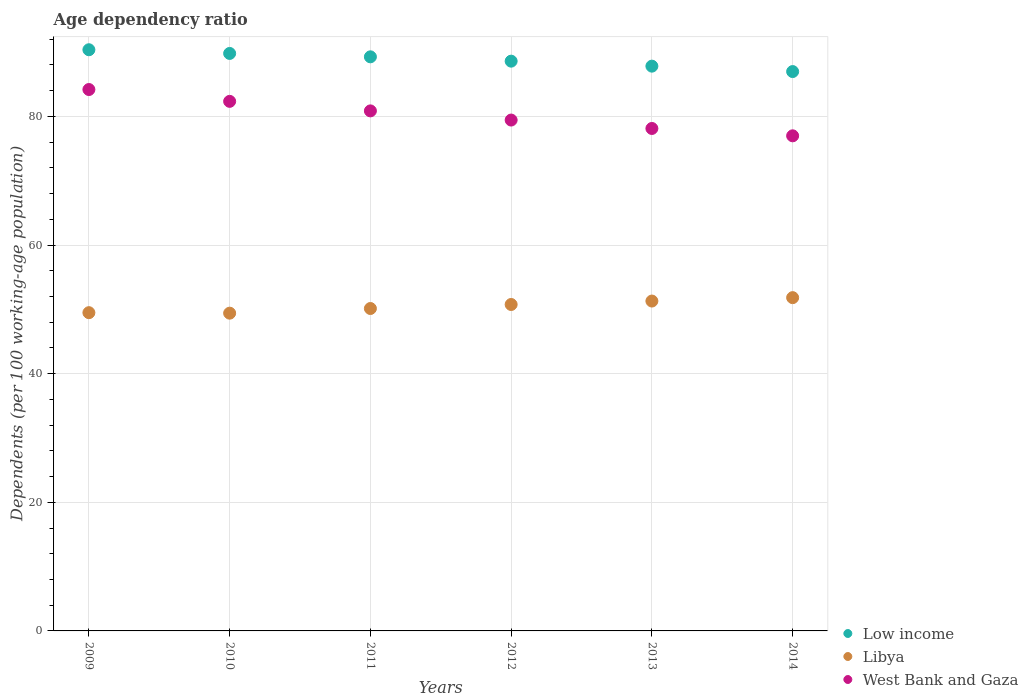Is the number of dotlines equal to the number of legend labels?
Offer a terse response. Yes. What is the age dependency ratio in in Low income in 2013?
Give a very brief answer. 87.81. Across all years, what is the maximum age dependency ratio in in Libya?
Offer a terse response. 51.82. Across all years, what is the minimum age dependency ratio in in West Bank and Gaza?
Keep it short and to the point. 76.98. In which year was the age dependency ratio in in Libya maximum?
Your answer should be compact. 2014. What is the total age dependency ratio in in Low income in the graph?
Offer a very short reply. 532.76. What is the difference between the age dependency ratio in in West Bank and Gaza in 2010 and that in 2012?
Your answer should be very brief. 2.91. What is the difference between the age dependency ratio in in Low income in 2011 and the age dependency ratio in in West Bank and Gaza in 2012?
Your answer should be compact. 9.83. What is the average age dependency ratio in in Low income per year?
Provide a succinct answer. 88.79. In the year 2012, what is the difference between the age dependency ratio in in Libya and age dependency ratio in in West Bank and Gaza?
Your answer should be compact. -28.68. What is the ratio of the age dependency ratio in in Libya in 2009 to that in 2010?
Make the answer very short. 1. Is the age dependency ratio in in Low income in 2009 less than that in 2011?
Your answer should be very brief. No. Is the difference between the age dependency ratio in in Libya in 2011 and 2013 greater than the difference between the age dependency ratio in in West Bank and Gaza in 2011 and 2013?
Provide a succinct answer. No. What is the difference between the highest and the second highest age dependency ratio in in Libya?
Your answer should be compact. 0.53. What is the difference between the highest and the lowest age dependency ratio in in Libya?
Make the answer very short. 2.41. Is it the case that in every year, the sum of the age dependency ratio in in West Bank and Gaza and age dependency ratio in in Libya  is greater than the age dependency ratio in in Low income?
Provide a succinct answer. Yes. Does the age dependency ratio in in West Bank and Gaza monotonically increase over the years?
Ensure brevity in your answer.  No. How many years are there in the graph?
Give a very brief answer. 6. What is the difference between two consecutive major ticks on the Y-axis?
Your answer should be very brief. 20. Are the values on the major ticks of Y-axis written in scientific E-notation?
Provide a short and direct response. No. Does the graph contain any zero values?
Give a very brief answer. No. Does the graph contain grids?
Ensure brevity in your answer.  Yes. What is the title of the graph?
Your answer should be very brief. Age dependency ratio. What is the label or title of the Y-axis?
Offer a very short reply. Dependents (per 100 working-age population). What is the Dependents (per 100 working-age population) in Low income in 2009?
Give a very brief answer. 90.36. What is the Dependents (per 100 working-age population) in Libya in 2009?
Ensure brevity in your answer.  49.48. What is the Dependents (per 100 working-age population) of West Bank and Gaza in 2009?
Ensure brevity in your answer.  84.17. What is the Dependents (per 100 working-age population) in Low income in 2010?
Offer a very short reply. 89.78. What is the Dependents (per 100 working-age population) in Libya in 2010?
Your answer should be compact. 49.4. What is the Dependents (per 100 working-age population) of West Bank and Gaza in 2010?
Your answer should be very brief. 82.33. What is the Dependents (per 100 working-age population) in Low income in 2011?
Your response must be concise. 89.26. What is the Dependents (per 100 working-age population) in Libya in 2011?
Your answer should be compact. 50.13. What is the Dependents (per 100 working-age population) of West Bank and Gaza in 2011?
Provide a short and direct response. 80.85. What is the Dependents (per 100 working-age population) in Low income in 2012?
Your answer should be compact. 88.58. What is the Dependents (per 100 working-age population) of Libya in 2012?
Give a very brief answer. 50.75. What is the Dependents (per 100 working-age population) of West Bank and Gaza in 2012?
Your response must be concise. 79.43. What is the Dependents (per 100 working-age population) of Low income in 2013?
Offer a very short reply. 87.81. What is the Dependents (per 100 working-age population) in Libya in 2013?
Your response must be concise. 51.29. What is the Dependents (per 100 working-age population) in West Bank and Gaza in 2013?
Offer a terse response. 78.12. What is the Dependents (per 100 working-age population) in Low income in 2014?
Ensure brevity in your answer.  86.97. What is the Dependents (per 100 working-age population) of Libya in 2014?
Your response must be concise. 51.82. What is the Dependents (per 100 working-age population) in West Bank and Gaza in 2014?
Provide a short and direct response. 76.98. Across all years, what is the maximum Dependents (per 100 working-age population) of Low income?
Your answer should be compact. 90.36. Across all years, what is the maximum Dependents (per 100 working-age population) in Libya?
Your answer should be very brief. 51.82. Across all years, what is the maximum Dependents (per 100 working-age population) of West Bank and Gaza?
Make the answer very short. 84.17. Across all years, what is the minimum Dependents (per 100 working-age population) in Low income?
Your answer should be very brief. 86.97. Across all years, what is the minimum Dependents (per 100 working-age population) in Libya?
Your answer should be very brief. 49.4. Across all years, what is the minimum Dependents (per 100 working-age population) in West Bank and Gaza?
Give a very brief answer. 76.98. What is the total Dependents (per 100 working-age population) of Low income in the graph?
Make the answer very short. 532.76. What is the total Dependents (per 100 working-age population) of Libya in the graph?
Provide a succinct answer. 302.86. What is the total Dependents (per 100 working-age population) in West Bank and Gaza in the graph?
Your answer should be compact. 481.88. What is the difference between the Dependents (per 100 working-age population) in Low income in 2009 and that in 2010?
Offer a terse response. 0.57. What is the difference between the Dependents (per 100 working-age population) in Libya in 2009 and that in 2010?
Give a very brief answer. 0.08. What is the difference between the Dependents (per 100 working-age population) in West Bank and Gaza in 2009 and that in 2010?
Give a very brief answer. 1.84. What is the difference between the Dependents (per 100 working-age population) in Low income in 2009 and that in 2011?
Provide a short and direct response. 1.1. What is the difference between the Dependents (per 100 working-age population) of Libya in 2009 and that in 2011?
Ensure brevity in your answer.  -0.65. What is the difference between the Dependents (per 100 working-age population) in West Bank and Gaza in 2009 and that in 2011?
Provide a short and direct response. 3.32. What is the difference between the Dependents (per 100 working-age population) in Low income in 2009 and that in 2012?
Your response must be concise. 1.77. What is the difference between the Dependents (per 100 working-age population) in Libya in 2009 and that in 2012?
Offer a terse response. -1.27. What is the difference between the Dependents (per 100 working-age population) in West Bank and Gaza in 2009 and that in 2012?
Your response must be concise. 4.75. What is the difference between the Dependents (per 100 working-age population) in Low income in 2009 and that in 2013?
Make the answer very short. 2.55. What is the difference between the Dependents (per 100 working-age population) in Libya in 2009 and that in 2013?
Make the answer very short. -1.81. What is the difference between the Dependents (per 100 working-age population) in West Bank and Gaza in 2009 and that in 2013?
Keep it short and to the point. 6.06. What is the difference between the Dependents (per 100 working-age population) of Low income in 2009 and that in 2014?
Offer a terse response. 3.39. What is the difference between the Dependents (per 100 working-age population) in Libya in 2009 and that in 2014?
Keep it short and to the point. -2.34. What is the difference between the Dependents (per 100 working-age population) in West Bank and Gaza in 2009 and that in 2014?
Make the answer very short. 7.2. What is the difference between the Dependents (per 100 working-age population) in Low income in 2010 and that in 2011?
Your answer should be compact. 0.53. What is the difference between the Dependents (per 100 working-age population) of Libya in 2010 and that in 2011?
Your answer should be very brief. -0.72. What is the difference between the Dependents (per 100 working-age population) in West Bank and Gaza in 2010 and that in 2011?
Offer a terse response. 1.48. What is the difference between the Dependents (per 100 working-age population) in Low income in 2010 and that in 2012?
Give a very brief answer. 1.2. What is the difference between the Dependents (per 100 working-age population) of Libya in 2010 and that in 2012?
Keep it short and to the point. -1.35. What is the difference between the Dependents (per 100 working-age population) in West Bank and Gaza in 2010 and that in 2012?
Offer a very short reply. 2.91. What is the difference between the Dependents (per 100 working-age population) of Low income in 2010 and that in 2013?
Your response must be concise. 1.98. What is the difference between the Dependents (per 100 working-age population) in Libya in 2010 and that in 2013?
Keep it short and to the point. -1.89. What is the difference between the Dependents (per 100 working-age population) of West Bank and Gaza in 2010 and that in 2013?
Make the answer very short. 4.22. What is the difference between the Dependents (per 100 working-age population) of Low income in 2010 and that in 2014?
Offer a very short reply. 2.82. What is the difference between the Dependents (per 100 working-age population) of Libya in 2010 and that in 2014?
Make the answer very short. -2.41. What is the difference between the Dependents (per 100 working-age population) in West Bank and Gaza in 2010 and that in 2014?
Your answer should be very brief. 5.36. What is the difference between the Dependents (per 100 working-age population) of Low income in 2011 and that in 2012?
Offer a very short reply. 0.67. What is the difference between the Dependents (per 100 working-age population) in Libya in 2011 and that in 2012?
Your response must be concise. -0.62. What is the difference between the Dependents (per 100 working-age population) of West Bank and Gaza in 2011 and that in 2012?
Your answer should be very brief. 1.43. What is the difference between the Dependents (per 100 working-age population) in Low income in 2011 and that in 2013?
Keep it short and to the point. 1.45. What is the difference between the Dependents (per 100 working-age population) in Libya in 2011 and that in 2013?
Provide a succinct answer. -1.16. What is the difference between the Dependents (per 100 working-age population) in West Bank and Gaza in 2011 and that in 2013?
Give a very brief answer. 2.73. What is the difference between the Dependents (per 100 working-age population) in Low income in 2011 and that in 2014?
Your answer should be very brief. 2.29. What is the difference between the Dependents (per 100 working-age population) in Libya in 2011 and that in 2014?
Your answer should be compact. -1.69. What is the difference between the Dependents (per 100 working-age population) in West Bank and Gaza in 2011 and that in 2014?
Provide a short and direct response. 3.88. What is the difference between the Dependents (per 100 working-age population) in Low income in 2012 and that in 2013?
Your response must be concise. 0.78. What is the difference between the Dependents (per 100 working-age population) in Libya in 2012 and that in 2013?
Offer a terse response. -0.54. What is the difference between the Dependents (per 100 working-age population) in West Bank and Gaza in 2012 and that in 2013?
Provide a short and direct response. 1.31. What is the difference between the Dependents (per 100 working-age population) of Low income in 2012 and that in 2014?
Provide a succinct answer. 1.62. What is the difference between the Dependents (per 100 working-age population) in Libya in 2012 and that in 2014?
Offer a very short reply. -1.06. What is the difference between the Dependents (per 100 working-age population) in West Bank and Gaza in 2012 and that in 2014?
Offer a very short reply. 2.45. What is the difference between the Dependents (per 100 working-age population) in Low income in 2013 and that in 2014?
Your answer should be compact. 0.84. What is the difference between the Dependents (per 100 working-age population) of Libya in 2013 and that in 2014?
Give a very brief answer. -0.53. What is the difference between the Dependents (per 100 working-age population) of West Bank and Gaza in 2013 and that in 2014?
Your response must be concise. 1.14. What is the difference between the Dependents (per 100 working-age population) of Low income in 2009 and the Dependents (per 100 working-age population) of Libya in 2010?
Ensure brevity in your answer.  40.96. What is the difference between the Dependents (per 100 working-age population) of Low income in 2009 and the Dependents (per 100 working-age population) of West Bank and Gaza in 2010?
Keep it short and to the point. 8.02. What is the difference between the Dependents (per 100 working-age population) of Libya in 2009 and the Dependents (per 100 working-age population) of West Bank and Gaza in 2010?
Offer a very short reply. -32.85. What is the difference between the Dependents (per 100 working-age population) of Low income in 2009 and the Dependents (per 100 working-age population) of Libya in 2011?
Give a very brief answer. 40.23. What is the difference between the Dependents (per 100 working-age population) of Low income in 2009 and the Dependents (per 100 working-age population) of West Bank and Gaza in 2011?
Provide a short and direct response. 9.51. What is the difference between the Dependents (per 100 working-age population) of Libya in 2009 and the Dependents (per 100 working-age population) of West Bank and Gaza in 2011?
Ensure brevity in your answer.  -31.37. What is the difference between the Dependents (per 100 working-age population) of Low income in 2009 and the Dependents (per 100 working-age population) of Libya in 2012?
Your response must be concise. 39.61. What is the difference between the Dependents (per 100 working-age population) in Low income in 2009 and the Dependents (per 100 working-age population) in West Bank and Gaza in 2012?
Offer a very short reply. 10.93. What is the difference between the Dependents (per 100 working-age population) of Libya in 2009 and the Dependents (per 100 working-age population) of West Bank and Gaza in 2012?
Your answer should be compact. -29.95. What is the difference between the Dependents (per 100 working-age population) in Low income in 2009 and the Dependents (per 100 working-age population) in Libya in 2013?
Give a very brief answer. 39.07. What is the difference between the Dependents (per 100 working-age population) in Low income in 2009 and the Dependents (per 100 working-age population) in West Bank and Gaza in 2013?
Make the answer very short. 12.24. What is the difference between the Dependents (per 100 working-age population) of Libya in 2009 and the Dependents (per 100 working-age population) of West Bank and Gaza in 2013?
Your answer should be compact. -28.64. What is the difference between the Dependents (per 100 working-age population) in Low income in 2009 and the Dependents (per 100 working-age population) in Libya in 2014?
Make the answer very short. 38.54. What is the difference between the Dependents (per 100 working-age population) of Low income in 2009 and the Dependents (per 100 working-age population) of West Bank and Gaza in 2014?
Make the answer very short. 13.38. What is the difference between the Dependents (per 100 working-age population) in Libya in 2009 and the Dependents (per 100 working-age population) in West Bank and Gaza in 2014?
Keep it short and to the point. -27.5. What is the difference between the Dependents (per 100 working-age population) in Low income in 2010 and the Dependents (per 100 working-age population) in Libya in 2011?
Keep it short and to the point. 39.66. What is the difference between the Dependents (per 100 working-age population) of Low income in 2010 and the Dependents (per 100 working-age population) of West Bank and Gaza in 2011?
Ensure brevity in your answer.  8.93. What is the difference between the Dependents (per 100 working-age population) in Libya in 2010 and the Dependents (per 100 working-age population) in West Bank and Gaza in 2011?
Give a very brief answer. -31.45. What is the difference between the Dependents (per 100 working-age population) of Low income in 2010 and the Dependents (per 100 working-age population) of Libya in 2012?
Provide a succinct answer. 39.03. What is the difference between the Dependents (per 100 working-age population) in Low income in 2010 and the Dependents (per 100 working-age population) in West Bank and Gaza in 2012?
Make the answer very short. 10.36. What is the difference between the Dependents (per 100 working-age population) in Libya in 2010 and the Dependents (per 100 working-age population) in West Bank and Gaza in 2012?
Make the answer very short. -30.02. What is the difference between the Dependents (per 100 working-age population) of Low income in 2010 and the Dependents (per 100 working-age population) of Libya in 2013?
Your response must be concise. 38.5. What is the difference between the Dependents (per 100 working-age population) in Low income in 2010 and the Dependents (per 100 working-age population) in West Bank and Gaza in 2013?
Your response must be concise. 11.67. What is the difference between the Dependents (per 100 working-age population) in Libya in 2010 and the Dependents (per 100 working-age population) in West Bank and Gaza in 2013?
Offer a very short reply. -28.72. What is the difference between the Dependents (per 100 working-age population) in Low income in 2010 and the Dependents (per 100 working-age population) in Libya in 2014?
Give a very brief answer. 37.97. What is the difference between the Dependents (per 100 working-age population) of Low income in 2010 and the Dependents (per 100 working-age population) of West Bank and Gaza in 2014?
Ensure brevity in your answer.  12.81. What is the difference between the Dependents (per 100 working-age population) in Libya in 2010 and the Dependents (per 100 working-age population) in West Bank and Gaza in 2014?
Provide a succinct answer. -27.57. What is the difference between the Dependents (per 100 working-age population) of Low income in 2011 and the Dependents (per 100 working-age population) of Libya in 2012?
Provide a short and direct response. 38.51. What is the difference between the Dependents (per 100 working-age population) of Low income in 2011 and the Dependents (per 100 working-age population) of West Bank and Gaza in 2012?
Your answer should be very brief. 9.83. What is the difference between the Dependents (per 100 working-age population) in Libya in 2011 and the Dependents (per 100 working-age population) in West Bank and Gaza in 2012?
Provide a succinct answer. -29.3. What is the difference between the Dependents (per 100 working-age population) in Low income in 2011 and the Dependents (per 100 working-age population) in Libya in 2013?
Offer a very short reply. 37.97. What is the difference between the Dependents (per 100 working-age population) of Low income in 2011 and the Dependents (per 100 working-age population) of West Bank and Gaza in 2013?
Your answer should be compact. 11.14. What is the difference between the Dependents (per 100 working-age population) of Libya in 2011 and the Dependents (per 100 working-age population) of West Bank and Gaza in 2013?
Keep it short and to the point. -27.99. What is the difference between the Dependents (per 100 working-age population) in Low income in 2011 and the Dependents (per 100 working-age population) in Libya in 2014?
Your answer should be compact. 37.44. What is the difference between the Dependents (per 100 working-age population) in Low income in 2011 and the Dependents (per 100 working-age population) in West Bank and Gaza in 2014?
Make the answer very short. 12.28. What is the difference between the Dependents (per 100 working-age population) in Libya in 2011 and the Dependents (per 100 working-age population) in West Bank and Gaza in 2014?
Ensure brevity in your answer.  -26.85. What is the difference between the Dependents (per 100 working-age population) of Low income in 2012 and the Dependents (per 100 working-age population) of Libya in 2013?
Your answer should be compact. 37.3. What is the difference between the Dependents (per 100 working-age population) in Low income in 2012 and the Dependents (per 100 working-age population) in West Bank and Gaza in 2013?
Your response must be concise. 10.47. What is the difference between the Dependents (per 100 working-age population) of Libya in 2012 and the Dependents (per 100 working-age population) of West Bank and Gaza in 2013?
Your answer should be very brief. -27.37. What is the difference between the Dependents (per 100 working-age population) of Low income in 2012 and the Dependents (per 100 working-age population) of Libya in 2014?
Give a very brief answer. 36.77. What is the difference between the Dependents (per 100 working-age population) of Low income in 2012 and the Dependents (per 100 working-age population) of West Bank and Gaza in 2014?
Provide a short and direct response. 11.61. What is the difference between the Dependents (per 100 working-age population) in Libya in 2012 and the Dependents (per 100 working-age population) in West Bank and Gaza in 2014?
Provide a short and direct response. -26.22. What is the difference between the Dependents (per 100 working-age population) of Low income in 2013 and the Dependents (per 100 working-age population) of Libya in 2014?
Keep it short and to the point. 35.99. What is the difference between the Dependents (per 100 working-age population) in Low income in 2013 and the Dependents (per 100 working-age population) in West Bank and Gaza in 2014?
Ensure brevity in your answer.  10.83. What is the difference between the Dependents (per 100 working-age population) in Libya in 2013 and the Dependents (per 100 working-age population) in West Bank and Gaza in 2014?
Offer a very short reply. -25.69. What is the average Dependents (per 100 working-age population) in Low income per year?
Keep it short and to the point. 88.79. What is the average Dependents (per 100 working-age population) in Libya per year?
Provide a succinct answer. 50.48. What is the average Dependents (per 100 working-age population) in West Bank and Gaza per year?
Offer a very short reply. 80.31. In the year 2009, what is the difference between the Dependents (per 100 working-age population) of Low income and Dependents (per 100 working-age population) of Libya?
Keep it short and to the point. 40.88. In the year 2009, what is the difference between the Dependents (per 100 working-age population) in Low income and Dependents (per 100 working-age population) in West Bank and Gaza?
Provide a succinct answer. 6.18. In the year 2009, what is the difference between the Dependents (per 100 working-age population) in Libya and Dependents (per 100 working-age population) in West Bank and Gaza?
Your response must be concise. -34.69. In the year 2010, what is the difference between the Dependents (per 100 working-age population) of Low income and Dependents (per 100 working-age population) of Libya?
Provide a succinct answer. 40.38. In the year 2010, what is the difference between the Dependents (per 100 working-age population) in Low income and Dependents (per 100 working-age population) in West Bank and Gaza?
Your answer should be very brief. 7.45. In the year 2010, what is the difference between the Dependents (per 100 working-age population) in Libya and Dependents (per 100 working-age population) in West Bank and Gaza?
Keep it short and to the point. -32.93. In the year 2011, what is the difference between the Dependents (per 100 working-age population) in Low income and Dependents (per 100 working-age population) in Libya?
Your answer should be compact. 39.13. In the year 2011, what is the difference between the Dependents (per 100 working-age population) of Low income and Dependents (per 100 working-age population) of West Bank and Gaza?
Give a very brief answer. 8.41. In the year 2011, what is the difference between the Dependents (per 100 working-age population) in Libya and Dependents (per 100 working-age population) in West Bank and Gaza?
Make the answer very short. -30.73. In the year 2012, what is the difference between the Dependents (per 100 working-age population) in Low income and Dependents (per 100 working-age population) in Libya?
Your response must be concise. 37.83. In the year 2012, what is the difference between the Dependents (per 100 working-age population) of Low income and Dependents (per 100 working-age population) of West Bank and Gaza?
Provide a short and direct response. 9.16. In the year 2012, what is the difference between the Dependents (per 100 working-age population) of Libya and Dependents (per 100 working-age population) of West Bank and Gaza?
Ensure brevity in your answer.  -28.68. In the year 2013, what is the difference between the Dependents (per 100 working-age population) in Low income and Dependents (per 100 working-age population) in Libya?
Make the answer very short. 36.52. In the year 2013, what is the difference between the Dependents (per 100 working-age population) in Low income and Dependents (per 100 working-age population) in West Bank and Gaza?
Provide a succinct answer. 9.69. In the year 2013, what is the difference between the Dependents (per 100 working-age population) of Libya and Dependents (per 100 working-age population) of West Bank and Gaza?
Your answer should be very brief. -26.83. In the year 2014, what is the difference between the Dependents (per 100 working-age population) in Low income and Dependents (per 100 working-age population) in Libya?
Ensure brevity in your answer.  35.15. In the year 2014, what is the difference between the Dependents (per 100 working-age population) in Low income and Dependents (per 100 working-age population) in West Bank and Gaza?
Provide a short and direct response. 9.99. In the year 2014, what is the difference between the Dependents (per 100 working-age population) in Libya and Dependents (per 100 working-age population) in West Bank and Gaza?
Provide a short and direct response. -25.16. What is the ratio of the Dependents (per 100 working-age population) of Low income in 2009 to that in 2010?
Provide a succinct answer. 1.01. What is the ratio of the Dependents (per 100 working-age population) in Libya in 2009 to that in 2010?
Provide a succinct answer. 1. What is the ratio of the Dependents (per 100 working-age population) of West Bank and Gaza in 2009 to that in 2010?
Provide a succinct answer. 1.02. What is the ratio of the Dependents (per 100 working-age population) in Low income in 2009 to that in 2011?
Your answer should be very brief. 1.01. What is the ratio of the Dependents (per 100 working-age population) of Libya in 2009 to that in 2011?
Your answer should be very brief. 0.99. What is the ratio of the Dependents (per 100 working-age population) of West Bank and Gaza in 2009 to that in 2011?
Provide a succinct answer. 1.04. What is the ratio of the Dependents (per 100 working-age population) of Libya in 2009 to that in 2012?
Offer a very short reply. 0.97. What is the ratio of the Dependents (per 100 working-age population) in West Bank and Gaza in 2009 to that in 2012?
Ensure brevity in your answer.  1.06. What is the ratio of the Dependents (per 100 working-age population) of Low income in 2009 to that in 2013?
Your response must be concise. 1.03. What is the ratio of the Dependents (per 100 working-age population) of Libya in 2009 to that in 2013?
Your answer should be compact. 0.96. What is the ratio of the Dependents (per 100 working-age population) in West Bank and Gaza in 2009 to that in 2013?
Your answer should be very brief. 1.08. What is the ratio of the Dependents (per 100 working-age population) of Low income in 2009 to that in 2014?
Your response must be concise. 1.04. What is the ratio of the Dependents (per 100 working-age population) of Libya in 2009 to that in 2014?
Make the answer very short. 0.95. What is the ratio of the Dependents (per 100 working-age population) of West Bank and Gaza in 2009 to that in 2014?
Your answer should be very brief. 1.09. What is the ratio of the Dependents (per 100 working-age population) of Low income in 2010 to that in 2011?
Your answer should be compact. 1.01. What is the ratio of the Dependents (per 100 working-age population) of Libya in 2010 to that in 2011?
Your answer should be very brief. 0.99. What is the ratio of the Dependents (per 100 working-age population) in West Bank and Gaza in 2010 to that in 2011?
Give a very brief answer. 1.02. What is the ratio of the Dependents (per 100 working-age population) of Low income in 2010 to that in 2012?
Give a very brief answer. 1.01. What is the ratio of the Dependents (per 100 working-age population) in Libya in 2010 to that in 2012?
Your answer should be very brief. 0.97. What is the ratio of the Dependents (per 100 working-age population) of West Bank and Gaza in 2010 to that in 2012?
Keep it short and to the point. 1.04. What is the ratio of the Dependents (per 100 working-age population) of Low income in 2010 to that in 2013?
Make the answer very short. 1.02. What is the ratio of the Dependents (per 100 working-age population) in Libya in 2010 to that in 2013?
Your answer should be very brief. 0.96. What is the ratio of the Dependents (per 100 working-age population) of West Bank and Gaza in 2010 to that in 2013?
Your response must be concise. 1.05. What is the ratio of the Dependents (per 100 working-age population) of Low income in 2010 to that in 2014?
Keep it short and to the point. 1.03. What is the ratio of the Dependents (per 100 working-age population) of Libya in 2010 to that in 2014?
Provide a short and direct response. 0.95. What is the ratio of the Dependents (per 100 working-age population) of West Bank and Gaza in 2010 to that in 2014?
Provide a short and direct response. 1.07. What is the ratio of the Dependents (per 100 working-age population) in Low income in 2011 to that in 2012?
Give a very brief answer. 1.01. What is the ratio of the Dependents (per 100 working-age population) of West Bank and Gaza in 2011 to that in 2012?
Give a very brief answer. 1.02. What is the ratio of the Dependents (per 100 working-age population) of Low income in 2011 to that in 2013?
Provide a succinct answer. 1.02. What is the ratio of the Dependents (per 100 working-age population) in Libya in 2011 to that in 2013?
Your response must be concise. 0.98. What is the ratio of the Dependents (per 100 working-age population) in West Bank and Gaza in 2011 to that in 2013?
Your response must be concise. 1.03. What is the ratio of the Dependents (per 100 working-age population) in Low income in 2011 to that in 2014?
Offer a very short reply. 1.03. What is the ratio of the Dependents (per 100 working-age population) of Libya in 2011 to that in 2014?
Ensure brevity in your answer.  0.97. What is the ratio of the Dependents (per 100 working-age population) of West Bank and Gaza in 2011 to that in 2014?
Make the answer very short. 1.05. What is the ratio of the Dependents (per 100 working-age population) of Low income in 2012 to that in 2013?
Provide a short and direct response. 1.01. What is the ratio of the Dependents (per 100 working-age population) in West Bank and Gaza in 2012 to that in 2013?
Your answer should be compact. 1.02. What is the ratio of the Dependents (per 100 working-age population) in Low income in 2012 to that in 2014?
Your answer should be compact. 1.02. What is the ratio of the Dependents (per 100 working-age population) in Libya in 2012 to that in 2014?
Make the answer very short. 0.98. What is the ratio of the Dependents (per 100 working-age population) in West Bank and Gaza in 2012 to that in 2014?
Your response must be concise. 1.03. What is the ratio of the Dependents (per 100 working-age population) in Low income in 2013 to that in 2014?
Offer a terse response. 1.01. What is the ratio of the Dependents (per 100 working-age population) of Libya in 2013 to that in 2014?
Your response must be concise. 0.99. What is the ratio of the Dependents (per 100 working-age population) of West Bank and Gaza in 2013 to that in 2014?
Ensure brevity in your answer.  1.01. What is the difference between the highest and the second highest Dependents (per 100 working-age population) in Low income?
Ensure brevity in your answer.  0.57. What is the difference between the highest and the second highest Dependents (per 100 working-age population) of Libya?
Offer a terse response. 0.53. What is the difference between the highest and the second highest Dependents (per 100 working-age population) in West Bank and Gaza?
Your response must be concise. 1.84. What is the difference between the highest and the lowest Dependents (per 100 working-age population) of Low income?
Make the answer very short. 3.39. What is the difference between the highest and the lowest Dependents (per 100 working-age population) of Libya?
Ensure brevity in your answer.  2.41. What is the difference between the highest and the lowest Dependents (per 100 working-age population) in West Bank and Gaza?
Your answer should be very brief. 7.2. 